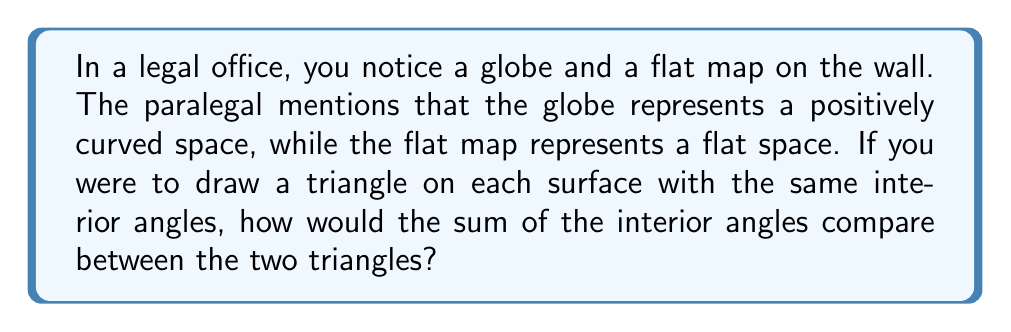What is the answer to this math problem? Let's approach this step-by-step:

1) In Euclidean (flat) geometry, the sum of interior angles of a triangle is always 180°. This is represented by the flat map.

2) On a positively curved surface, like a sphere (represented by the globe), the sum of interior angles of a triangle is always greater than 180°.

3) The reason for this difference lies in the concept of curvature:
   - Flat space has zero curvature
   - The globe has positive curvature

4) On a positively curved surface, the "straight" lines (geodesics) actually curve towards each other. This results in the angles of a triangle adding up to more than 180°.

5) The excess angle (amount over 180°) is directly proportional to the area of the triangle and the curvature of the surface.

6) Mathematically, for a triangle on a sphere with radius $R$ and area $A$, the sum of angles $\theta$ is given by:

   $$\theta = \pi + \frac{A}{R^2}$$

   Where $\pi$ radians = 180°

7) Therefore, the triangle on the globe (positively curved space) will have a greater sum of interior angles compared to the triangle on the flat map (flat space).
Answer: The sum of interior angles is greater on the globe (curved space) than on the flat map (flat space). 